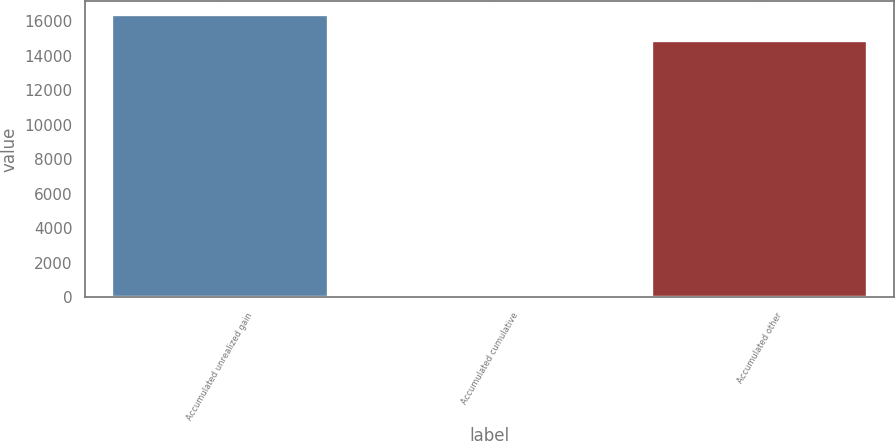Convert chart. <chart><loc_0><loc_0><loc_500><loc_500><bar_chart><fcel>Accumulated unrealized gain<fcel>Accumulated cumulative<fcel>Accumulated other<nl><fcel>16340.5<fcel>129<fcel>14855<nl></chart> 